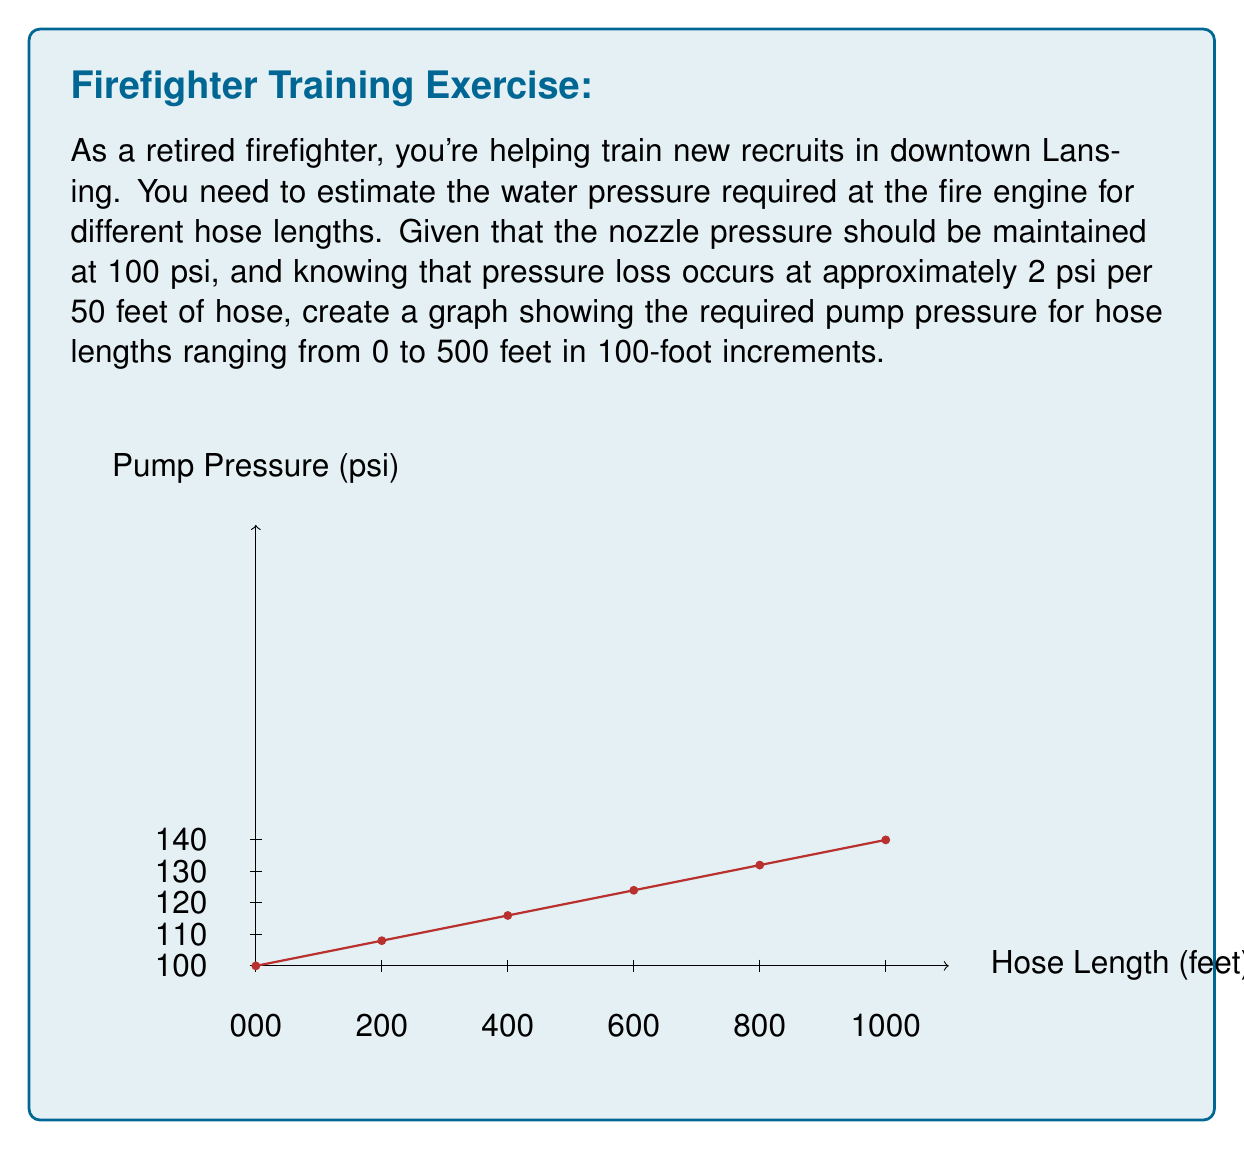Show me your answer to this math problem. To solve this problem, we need to follow these steps:

1) Understand the given information:
   - Nozzle pressure should be 100 psi
   - Pressure loss is 2 psi per 50 feet of hose

2) Calculate the pressure loss for each 100-foot increment:
   Pressure loss per 100 feet = $\frac{2 \text{ psi}}{50 \text{ feet}} \times 100 \text{ feet} = 4 \text{ psi}$

3) Calculate the required pump pressure for each length:
   Pump pressure = Nozzle pressure + Pressure loss

   For 0 feet:   $100 + 0 \times 4 = 100 \text{ psi}$
   For 100 feet: $100 + 1 \times 4 = 104 \text{ psi}$
   For 200 feet: $100 + 2 \times 4 = 108 \text{ psi}$
   For 300 feet: $100 + 3 \times 4 = 112 \text{ psi}$
   For 400 feet: $100 + 4 \times 4 = 116 \text{ psi}$
   For 500 feet: $100 + 5 \times 4 = 120 \text{ psi}$

4) Plot these points on the graph:
   (0, 100), (100, 104), (200, 108), (300, 112), (400, 116), (500, 120)

5) Connect the points to form a straight line, as the relationship between hose length and pump pressure is linear.

The resulting graph shows a clear linear relationship between hose length and required pump pressure, starting at 100 psi for 0 feet and increasing by 4 psi for every 100 feet of hose.
Answer: Linear graph from (0, 100) to (500, 120) 